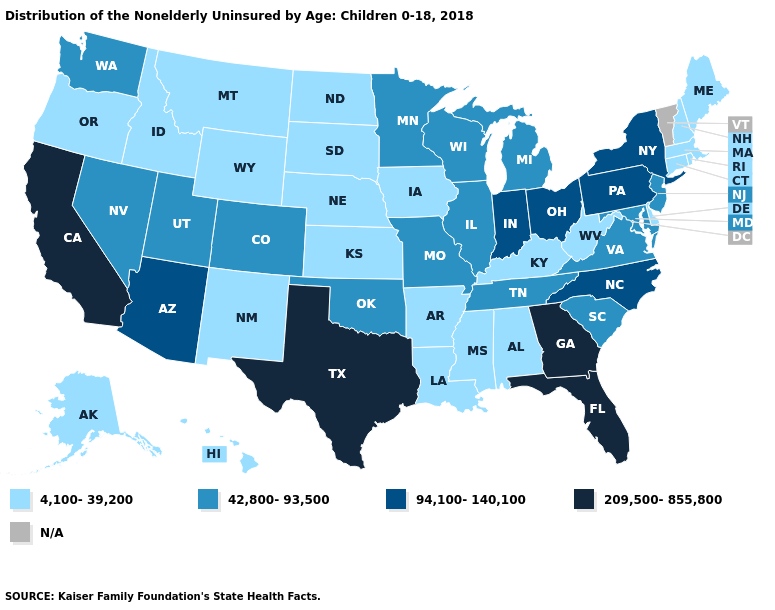What is the value of Arkansas?
Keep it brief. 4,100-39,200. Name the states that have a value in the range 94,100-140,100?
Keep it brief. Arizona, Indiana, New York, North Carolina, Ohio, Pennsylvania. What is the highest value in the MidWest ?
Write a very short answer. 94,100-140,100. Does New York have the lowest value in the USA?
Be succinct. No. Among the states that border Louisiana , which have the lowest value?
Give a very brief answer. Arkansas, Mississippi. Name the states that have a value in the range 42,800-93,500?
Be succinct. Colorado, Illinois, Maryland, Michigan, Minnesota, Missouri, Nevada, New Jersey, Oklahoma, South Carolina, Tennessee, Utah, Virginia, Washington, Wisconsin. Which states have the lowest value in the West?
Answer briefly. Alaska, Hawaii, Idaho, Montana, New Mexico, Oregon, Wyoming. What is the value of North Carolina?
Answer briefly. 94,100-140,100. What is the value of Louisiana?
Be succinct. 4,100-39,200. Does Kansas have the lowest value in the MidWest?
Write a very short answer. Yes. What is the highest value in states that border Kentucky?
Be succinct. 94,100-140,100. Among the states that border Pennsylvania , which have the lowest value?
Concise answer only. Delaware, West Virginia. Which states have the highest value in the USA?
Quick response, please. California, Florida, Georgia, Texas. Does Oklahoma have the lowest value in the South?
Keep it brief. No. What is the highest value in the USA?
Quick response, please. 209,500-855,800. 